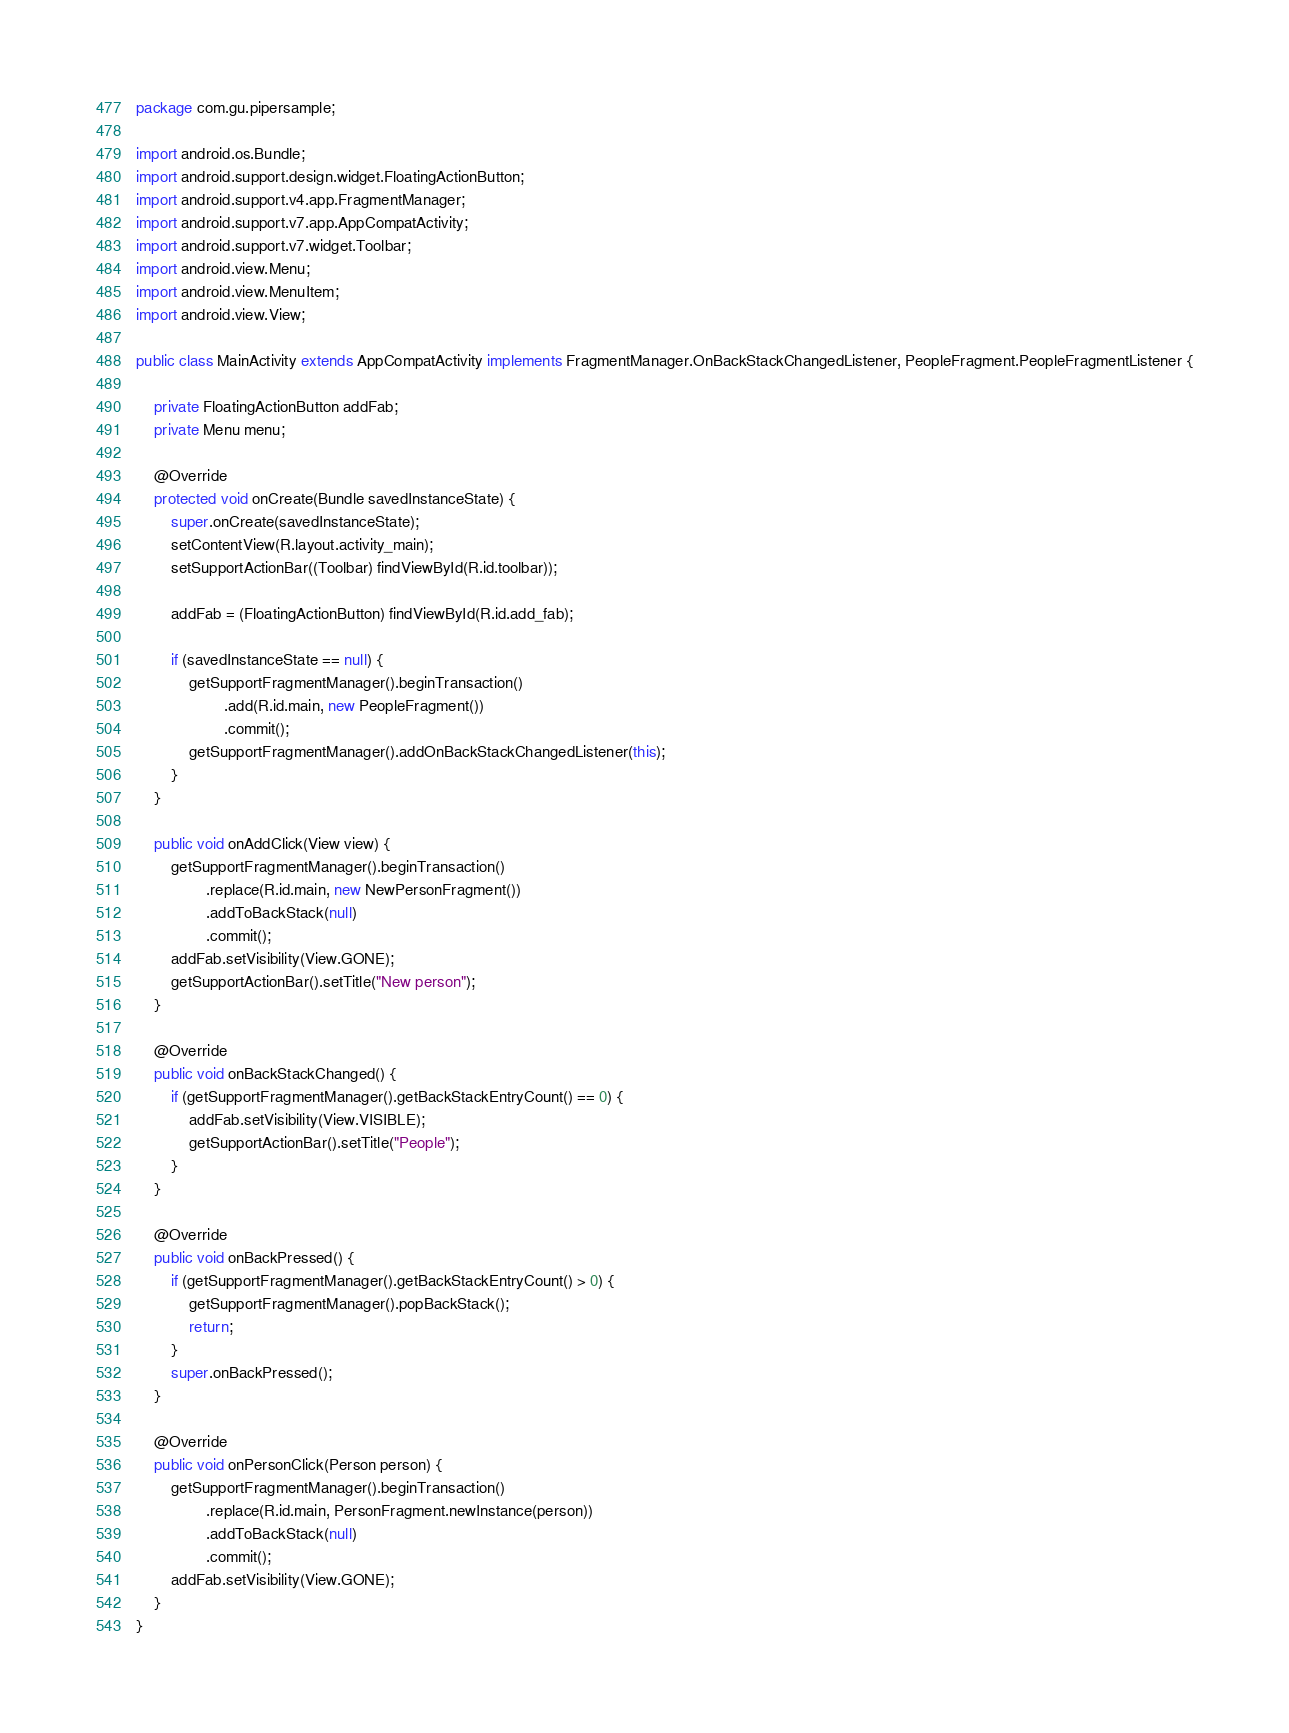Convert code to text. <code><loc_0><loc_0><loc_500><loc_500><_Java_>package com.gu.pipersample;

import android.os.Bundle;
import android.support.design.widget.FloatingActionButton;
import android.support.v4.app.FragmentManager;
import android.support.v7.app.AppCompatActivity;
import android.support.v7.widget.Toolbar;
import android.view.Menu;
import android.view.MenuItem;
import android.view.View;

public class MainActivity extends AppCompatActivity implements FragmentManager.OnBackStackChangedListener, PeopleFragment.PeopleFragmentListener {

    private FloatingActionButton addFab;
    private Menu menu;

    @Override
    protected void onCreate(Bundle savedInstanceState) {
        super.onCreate(savedInstanceState);
        setContentView(R.layout.activity_main);
        setSupportActionBar((Toolbar) findViewById(R.id.toolbar));

        addFab = (FloatingActionButton) findViewById(R.id.add_fab);

        if (savedInstanceState == null) {
            getSupportFragmentManager().beginTransaction()
                    .add(R.id.main, new PeopleFragment())
                    .commit();
            getSupportFragmentManager().addOnBackStackChangedListener(this);
        }
    }

    public void onAddClick(View view) {
        getSupportFragmentManager().beginTransaction()
                .replace(R.id.main, new NewPersonFragment())
                .addToBackStack(null)
                .commit();
        addFab.setVisibility(View.GONE);
        getSupportActionBar().setTitle("New person");
    }

    @Override
    public void onBackStackChanged() {
        if (getSupportFragmentManager().getBackStackEntryCount() == 0) {
            addFab.setVisibility(View.VISIBLE);
            getSupportActionBar().setTitle("People");
        }
    }

    @Override
    public void onBackPressed() {
        if (getSupportFragmentManager().getBackStackEntryCount() > 0) {
            getSupportFragmentManager().popBackStack();
            return;
        }
        super.onBackPressed();
    }

    @Override
    public void onPersonClick(Person person) {
        getSupportFragmentManager().beginTransaction()
                .replace(R.id.main, PersonFragment.newInstance(person))
                .addToBackStack(null)
                .commit();
        addFab.setVisibility(View.GONE);
    }
}
</code> 